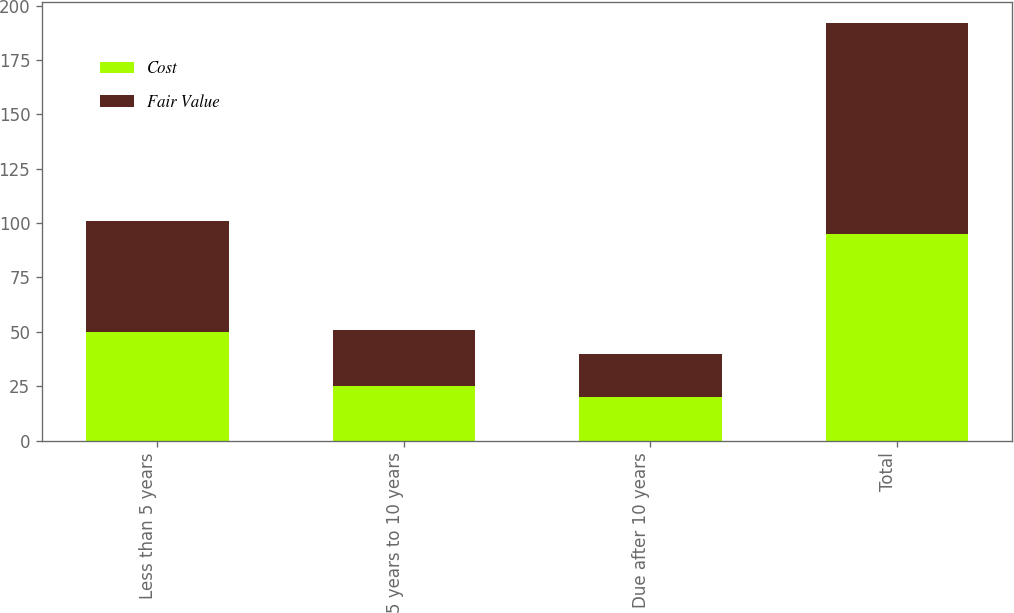Convert chart to OTSL. <chart><loc_0><loc_0><loc_500><loc_500><stacked_bar_chart><ecel><fcel>Less than 5 years<fcel>5 years to 10 years<fcel>Due after 10 years<fcel>Total<nl><fcel>Cost<fcel>50<fcel>25<fcel>20<fcel>95<nl><fcel>Fair Value<fcel>51<fcel>26<fcel>20<fcel>97<nl></chart> 